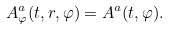Convert formula to latex. <formula><loc_0><loc_0><loc_500><loc_500>A ^ { a } _ { \varphi } ( t , r , \varphi ) = A ^ { a } ( t , \varphi ) .</formula> 